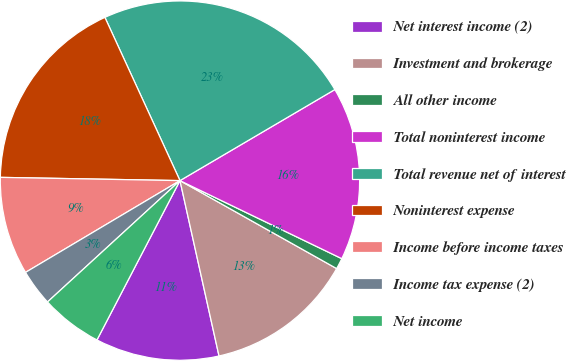Convert chart. <chart><loc_0><loc_0><loc_500><loc_500><pie_chart><fcel>Net interest income (2)<fcel>Investment and brokerage<fcel>All other income<fcel>Total noninterest income<fcel>Total revenue net of interest<fcel>Noninterest expense<fcel>Income before income taxes<fcel>Income tax expense (2)<fcel>Net income<nl><fcel>11.13%<fcel>13.37%<fcel>0.99%<fcel>15.61%<fcel>23.4%<fcel>17.85%<fcel>8.82%<fcel>3.27%<fcel>5.55%<nl></chart> 